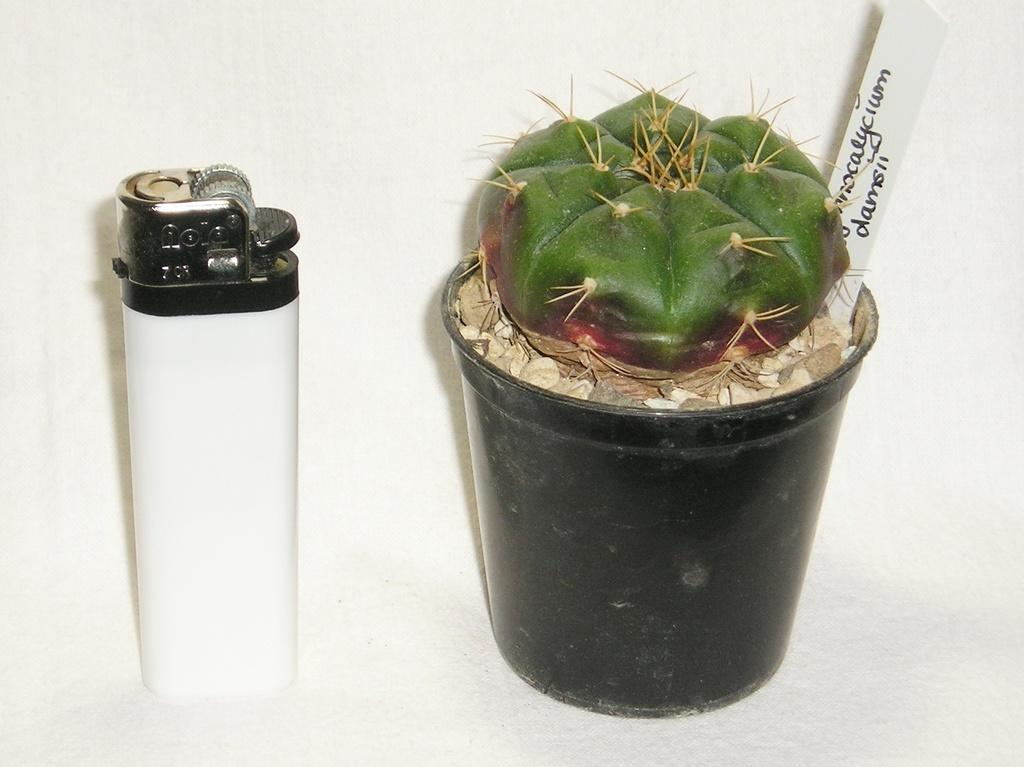What color is the flower pot in the image? The flower pot in the image is black. What is inside the flower pot? There is a plant in the pot. What object can be seen on the left side of the image? There is a lighter on the left side of the image. What is the paper in the image used for? There is a paper in the image with text on it. How many stitches are visible on the plant in the image? There are no stitches visible on the plant in the image, as it is a living organism and not a piece of fabric. What type of badge can be seen on the lighter in the image? There is no badge present on the lighter in the image. 